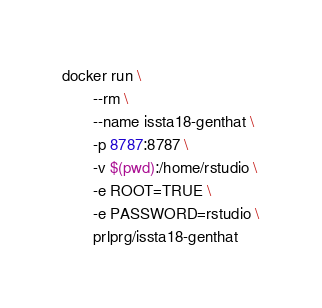Convert code to text. <code><loc_0><loc_0><loc_500><loc_500><_Bash_>docker run \
       --rm \
       --name issta18-genthat \
       -p 8787:8787 \
       -v $(pwd):/home/rstudio \
       -e ROOT=TRUE \
       -e PASSWORD=rstudio \
       prlprg/issta18-genthat
</code> 